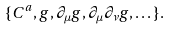Convert formula to latex. <formula><loc_0><loc_0><loc_500><loc_500>\{ C ^ { a } , g , \partial _ { \mu } g , \partial _ { \mu } \partial _ { \nu } g , \dots \} .</formula> 